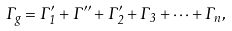Convert formula to latex. <formula><loc_0><loc_0><loc_500><loc_500>\Gamma _ { g } = \Gamma _ { 1 } ^ { \prime } + \Gamma ^ { \prime \prime } + \Gamma _ { 2 } ^ { \prime } + \Gamma _ { 3 } + \dots + \Gamma _ { n } ,</formula> 